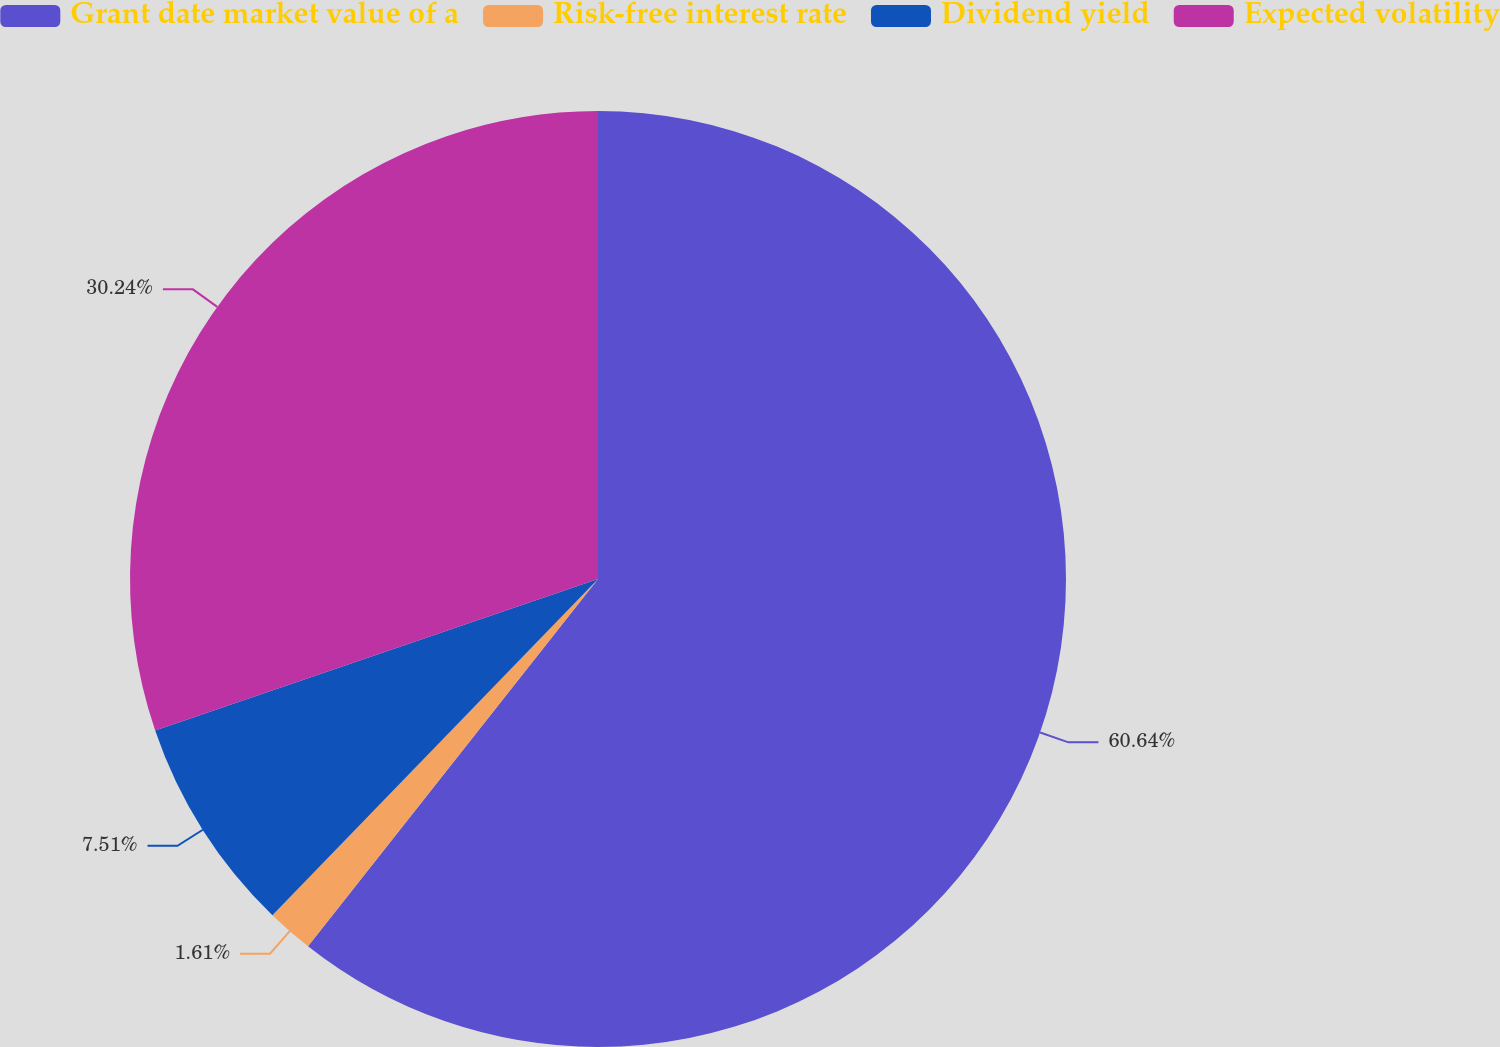Convert chart. <chart><loc_0><loc_0><loc_500><loc_500><pie_chart><fcel>Grant date market value of a<fcel>Risk-free interest rate<fcel>Dividend yield<fcel>Expected volatility<nl><fcel>60.63%<fcel>1.61%<fcel>7.51%<fcel>30.24%<nl></chart> 